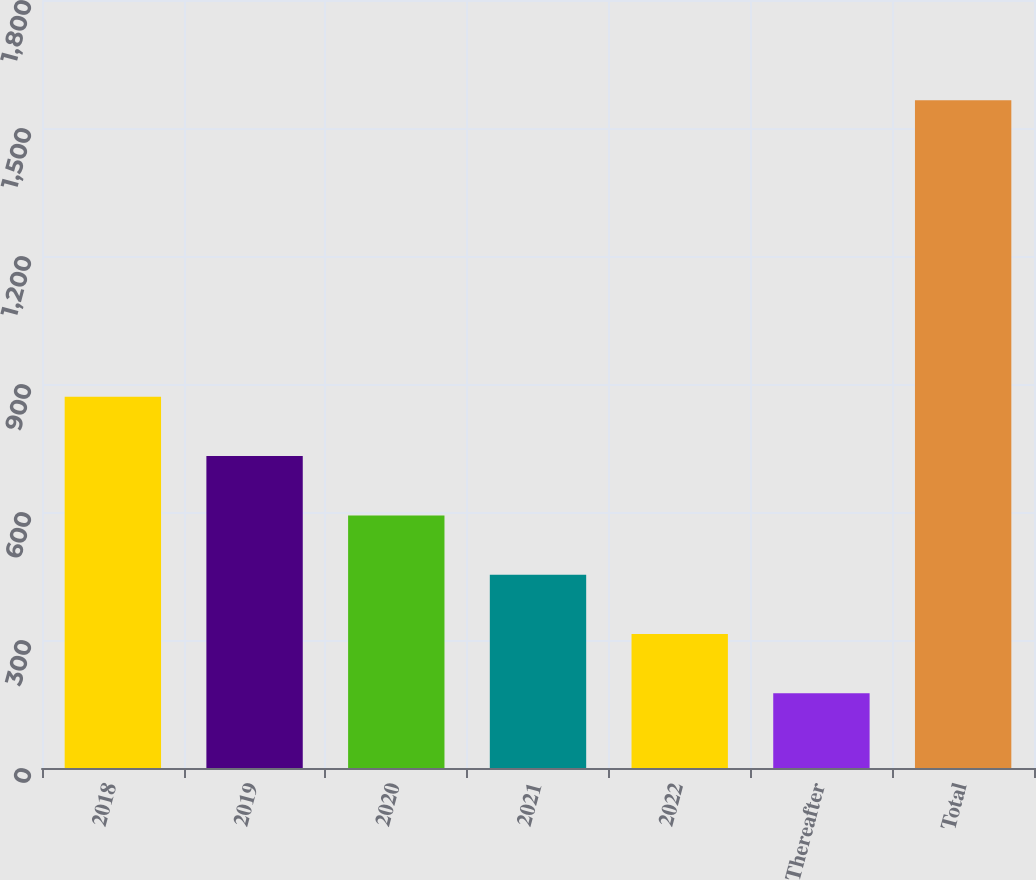Convert chart to OTSL. <chart><loc_0><loc_0><loc_500><loc_500><bar_chart><fcel>2018<fcel>2019<fcel>2020<fcel>2021<fcel>2022<fcel>Thereafter<fcel>Total<nl><fcel>870<fcel>731<fcel>592<fcel>453<fcel>314<fcel>175<fcel>1565<nl></chart> 